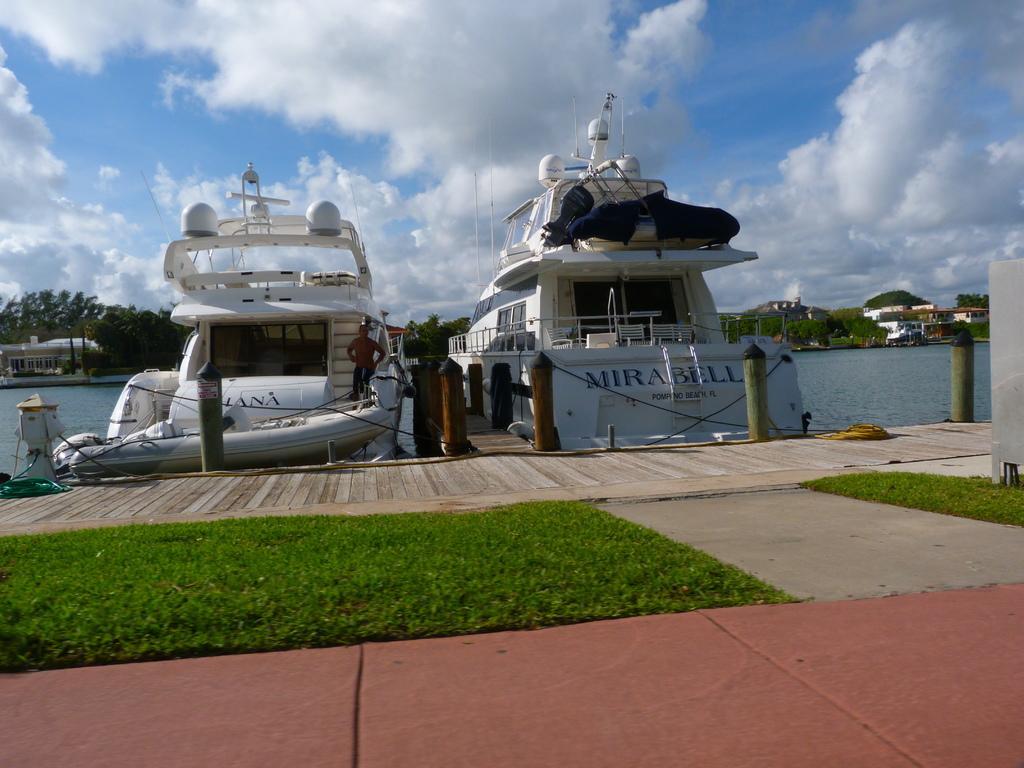In one or two sentences, can you explain what this image depicts? This image consists of two boats in white color. And we can see a man in the boat. At the bottom, there is green grass on the ground. In the background, we can see many trees and houses. In the middle, there is water. At the top, there are clouds in the sky. 